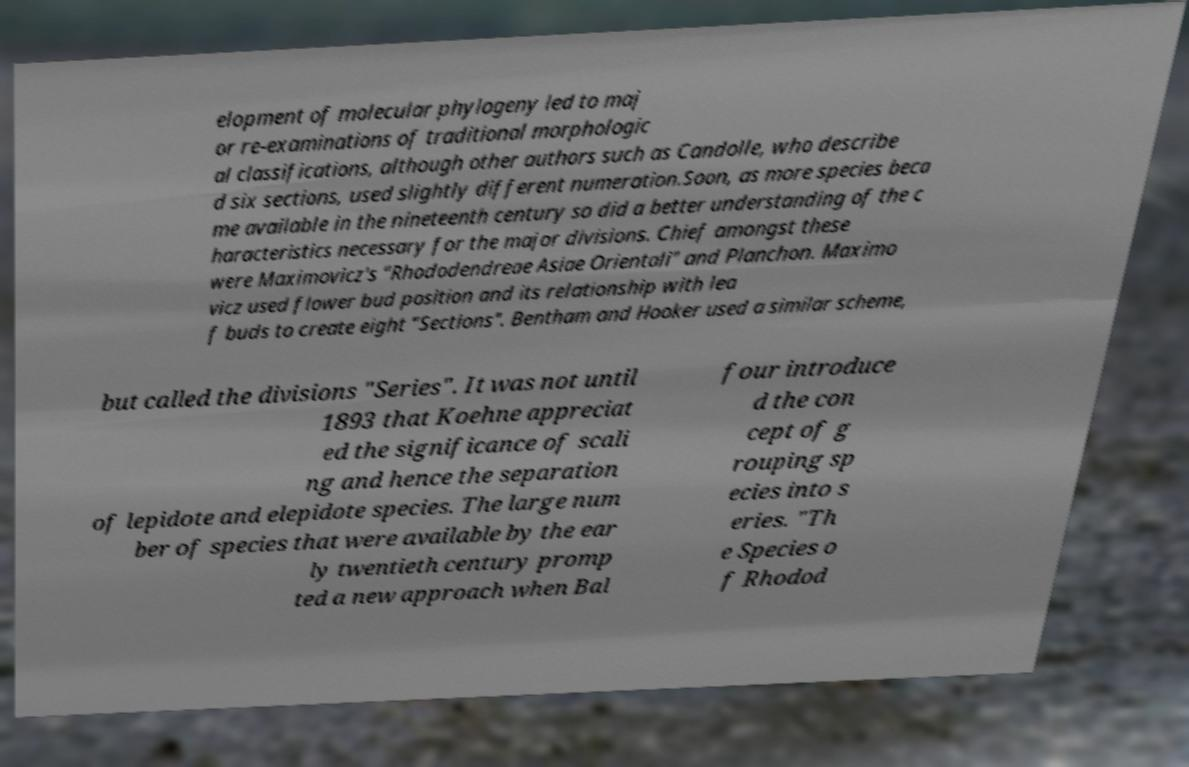I need the written content from this picture converted into text. Can you do that? elopment of molecular phylogeny led to maj or re-examinations of traditional morphologic al classifications, although other authors such as Candolle, who describe d six sections, used slightly different numeration.Soon, as more species beca me available in the nineteenth century so did a better understanding of the c haracteristics necessary for the major divisions. Chief amongst these were Maximovicz's "Rhododendreae Asiae Orientali" and Planchon. Maximo vicz used flower bud position and its relationship with lea f buds to create eight "Sections". Bentham and Hooker used a similar scheme, but called the divisions "Series". It was not until 1893 that Koehne appreciat ed the significance of scali ng and hence the separation of lepidote and elepidote species. The large num ber of species that were available by the ear ly twentieth century promp ted a new approach when Bal four introduce d the con cept of g rouping sp ecies into s eries. "Th e Species o f Rhodod 